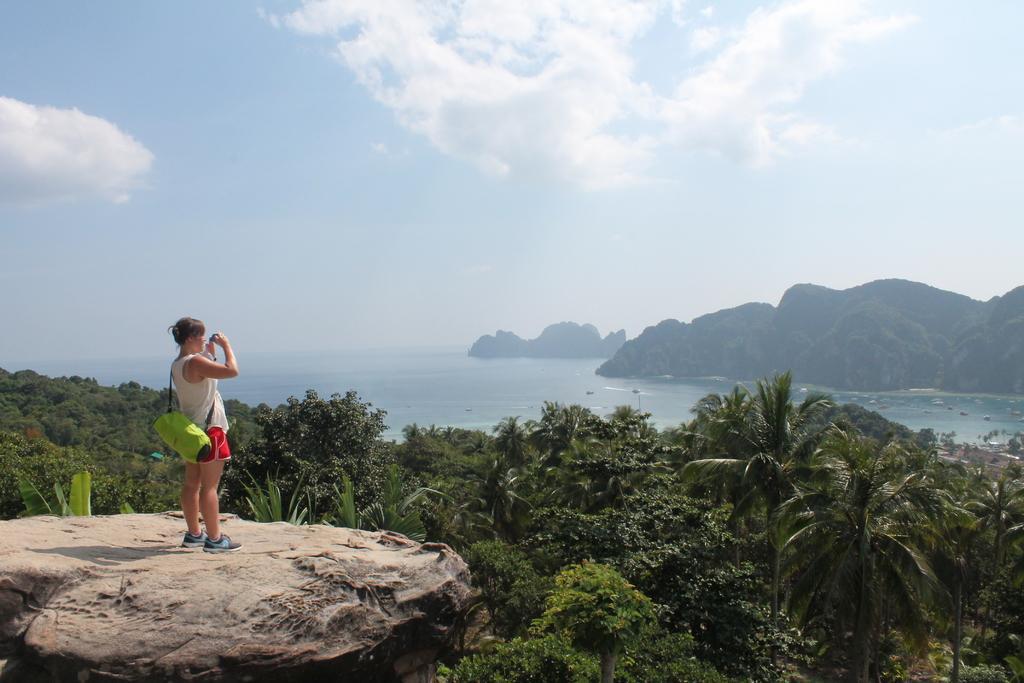How would you summarize this image in a sentence or two? In this picture there is a woman standing and holding the object. At the back there are mountains and there are boats on the water and there are trees. At the top there is sky and there are clouds. At the bottom left there is a rock. 